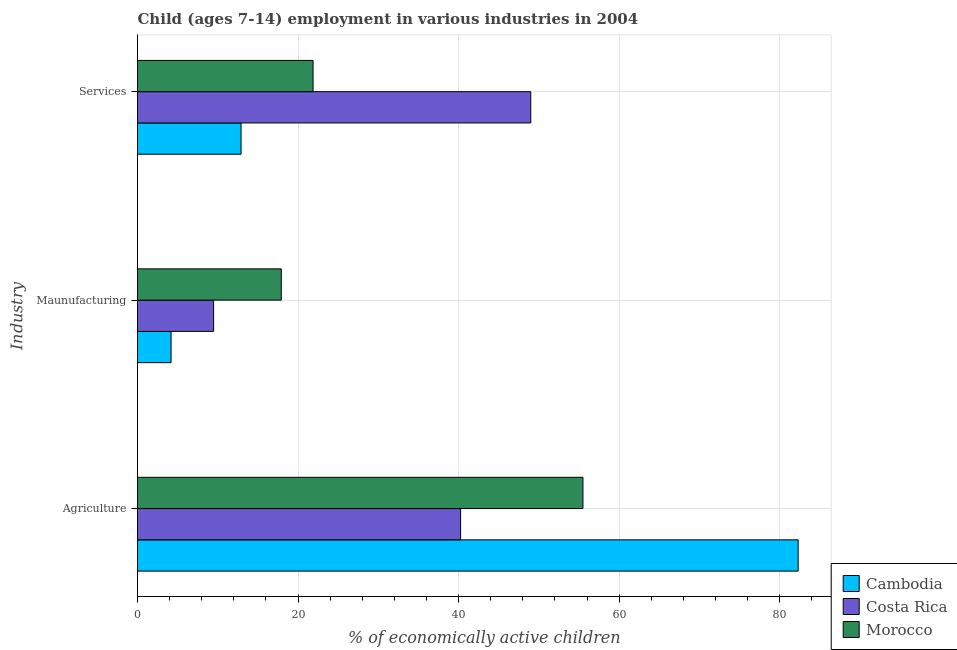Are the number of bars on each tick of the Y-axis equal?
Keep it short and to the point. Yes. How many bars are there on the 3rd tick from the top?
Provide a succinct answer. 3. How many bars are there on the 1st tick from the bottom?
Your response must be concise. 3. What is the label of the 3rd group of bars from the top?
Give a very brief answer. Agriculture. What is the percentage of economically active children in manufacturing in Morocco?
Provide a short and direct response. 17.91. Across all countries, what is the maximum percentage of economically active children in agriculture?
Make the answer very short. 82.3. Across all countries, what is the minimum percentage of economically active children in agriculture?
Ensure brevity in your answer.  40.25. In which country was the percentage of economically active children in agriculture maximum?
Offer a very short reply. Cambodia. What is the total percentage of economically active children in manufacturing in the graph?
Offer a very short reply. 31.57. What is the difference between the percentage of economically active children in manufacturing in Costa Rica and that in Morocco?
Offer a very short reply. -8.43. What is the difference between the percentage of economically active children in manufacturing in Morocco and the percentage of economically active children in services in Cambodia?
Ensure brevity in your answer.  5.01. What is the average percentage of economically active children in services per country?
Your answer should be very brief. 27.92. What is the difference between the percentage of economically active children in agriculture and percentage of economically active children in services in Morocco?
Provide a succinct answer. 33.62. In how many countries, is the percentage of economically active children in services greater than 60 %?
Ensure brevity in your answer.  0. What is the ratio of the percentage of economically active children in services in Cambodia to that in Costa Rica?
Make the answer very short. 0.26. Is the percentage of economically active children in agriculture in Morocco less than that in Costa Rica?
Offer a terse response. No. Is the difference between the percentage of economically active children in manufacturing in Cambodia and Costa Rica greater than the difference between the percentage of economically active children in services in Cambodia and Costa Rica?
Ensure brevity in your answer.  Yes. What is the difference between the highest and the second highest percentage of economically active children in manufacturing?
Provide a short and direct response. 8.43. What is the difference between the highest and the lowest percentage of economically active children in manufacturing?
Give a very brief answer. 13.73. In how many countries, is the percentage of economically active children in manufacturing greater than the average percentage of economically active children in manufacturing taken over all countries?
Your answer should be very brief. 1. What does the 2nd bar from the top in Agriculture represents?
Offer a terse response. Costa Rica. What does the 3rd bar from the bottom in Agriculture represents?
Offer a very short reply. Morocco. How many countries are there in the graph?
Offer a very short reply. 3. Are the values on the major ticks of X-axis written in scientific E-notation?
Your answer should be very brief. No. How many legend labels are there?
Provide a short and direct response. 3. What is the title of the graph?
Your answer should be compact. Child (ages 7-14) employment in various industries in 2004. What is the label or title of the X-axis?
Make the answer very short. % of economically active children. What is the label or title of the Y-axis?
Give a very brief answer. Industry. What is the % of economically active children in Cambodia in Agriculture?
Give a very brief answer. 82.3. What is the % of economically active children of Costa Rica in Agriculture?
Your response must be concise. 40.25. What is the % of economically active children of Morocco in Agriculture?
Your answer should be compact. 55.49. What is the % of economically active children of Cambodia in Maunufacturing?
Provide a short and direct response. 4.18. What is the % of economically active children in Costa Rica in Maunufacturing?
Keep it short and to the point. 9.48. What is the % of economically active children in Morocco in Maunufacturing?
Make the answer very short. 17.91. What is the % of economically active children of Costa Rica in Services?
Make the answer very short. 48.99. What is the % of economically active children of Morocco in Services?
Provide a short and direct response. 21.87. Across all Industry, what is the maximum % of economically active children in Cambodia?
Your response must be concise. 82.3. Across all Industry, what is the maximum % of economically active children in Costa Rica?
Make the answer very short. 48.99. Across all Industry, what is the maximum % of economically active children in Morocco?
Your answer should be very brief. 55.49. Across all Industry, what is the minimum % of economically active children in Cambodia?
Provide a short and direct response. 4.18. Across all Industry, what is the minimum % of economically active children in Costa Rica?
Provide a short and direct response. 9.48. Across all Industry, what is the minimum % of economically active children in Morocco?
Your answer should be very brief. 17.91. What is the total % of economically active children in Cambodia in the graph?
Keep it short and to the point. 99.38. What is the total % of economically active children of Costa Rica in the graph?
Provide a short and direct response. 98.72. What is the total % of economically active children in Morocco in the graph?
Your answer should be compact. 95.27. What is the difference between the % of economically active children in Cambodia in Agriculture and that in Maunufacturing?
Give a very brief answer. 78.12. What is the difference between the % of economically active children of Costa Rica in Agriculture and that in Maunufacturing?
Give a very brief answer. 30.77. What is the difference between the % of economically active children in Morocco in Agriculture and that in Maunufacturing?
Make the answer very short. 37.58. What is the difference between the % of economically active children of Cambodia in Agriculture and that in Services?
Offer a terse response. 69.4. What is the difference between the % of economically active children in Costa Rica in Agriculture and that in Services?
Your answer should be compact. -8.74. What is the difference between the % of economically active children of Morocco in Agriculture and that in Services?
Your response must be concise. 33.62. What is the difference between the % of economically active children of Cambodia in Maunufacturing and that in Services?
Offer a very short reply. -8.72. What is the difference between the % of economically active children of Costa Rica in Maunufacturing and that in Services?
Ensure brevity in your answer.  -39.51. What is the difference between the % of economically active children of Morocco in Maunufacturing and that in Services?
Make the answer very short. -3.96. What is the difference between the % of economically active children of Cambodia in Agriculture and the % of economically active children of Costa Rica in Maunufacturing?
Provide a succinct answer. 72.82. What is the difference between the % of economically active children in Cambodia in Agriculture and the % of economically active children in Morocco in Maunufacturing?
Keep it short and to the point. 64.39. What is the difference between the % of economically active children in Costa Rica in Agriculture and the % of economically active children in Morocco in Maunufacturing?
Your response must be concise. 22.34. What is the difference between the % of economically active children in Cambodia in Agriculture and the % of economically active children in Costa Rica in Services?
Offer a very short reply. 33.31. What is the difference between the % of economically active children of Cambodia in Agriculture and the % of economically active children of Morocco in Services?
Make the answer very short. 60.43. What is the difference between the % of economically active children in Costa Rica in Agriculture and the % of economically active children in Morocco in Services?
Your answer should be compact. 18.38. What is the difference between the % of economically active children of Cambodia in Maunufacturing and the % of economically active children of Costa Rica in Services?
Your answer should be very brief. -44.81. What is the difference between the % of economically active children of Cambodia in Maunufacturing and the % of economically active children of Morocco in Services?
Offer a terse response. -17.69. What is the difference between the % of economically active children in Costa Rica in Maunufacturing and the % of economically active children in Morocco in Services?
Keep it short and to the point. -12.39. What is the average % of economically active children of Cambodia per Industry?
Ensure brevity in your answer.  33.13. What is the average % of economically active children of Costa Rica per Industry?
Offer a very short reply. 32.91. What is the average % of economically active children in Morocco per Industry?
Offer a very short reply. 31.76. What is the difference between the % of economically active children of Cambodia and % of economically active children of Costa Rica in Agriculture?
Give a very brief answer. 42.05. What is the difference between the % of economically active children in Cambodia and % of economically active children in Morocco in Agriculture?
Your response must be concise. 26.81. What is the difference between the % of economically active children of Costa Rica and % of economically active children of Morocco in Agriculture?
Give a very brief answer. -15.24. What is the difference between the % of economically active children of Cambodia and % of economically active children of Morocco in Maunufacturing?
Keep it short and to the point. -13.73. What is the difference between the % of economically active children of Costa Rica and % of economically active children of Morocco in Maunufacturing?
Your answer should be compact. -8.43. What is the difference between the % of economically active children of Cambodia and % of economically active children of Costa Rica in Services?
Make the answer very short. -36.09. What is the difference between the % of economically active children of Cambodia and % of economically active children of Morocco in Services?
Your answer should be compact. -8.97. What is the difference between the % of economically active children in Costa Rica and % of economically active children in Morocco in Services?
Your response must be concise. 27.12. What is the ratio of the % of economically active children of Cambodia in Agriculture to that in Maunufacturing?
Provide a succinct answer. 19.69. What is the ratio of the % of economically active children of Costa Rica in Agriculture to that in Maunufacturing?
Ensure brevity in your answer.  4.25. What is the ratio of the % of economically active children of Morocco in Agriculture to that in Maunufacturing?
Your answer should be very brief. 3.1. What is the ratio of the % of economically active children in Cambodia in Agriculture to that in Services?
Offer a terse response. 6.38. What is the ratio of the % of economically active children in Costa Rica in Agriculture to that in Services?
Provide a short and direct response. 0.82. What is the ratio of the % of economically active children of Morocco in Agriculture to that in Services?
Provide a succinct answer. 2.54. What is the ratio of the % of economically active children in Cambodia in Maunufacturing to that in Services?
Your answer should be compact. 0.32. What is the ratio of the % of economically active children in Costa Rica in Maunufacturing to that in Services?
Your answer should be very brief. 0.19. What is the ratio of the % of economically active children of Morocco in Maunufacturing to that in Services?
Keep it short and to the point. 0.82. What is the difference between the highest and the second highest % of economically active children of Cambodia?
Keep it short and to the point. 69.4. What is the difference between the highest and the second highest % of economically active children in Costa Rica?
Provide a short and direct response. 8.74. What is the difference between the highest and the second highest % of economically active children in Morocco?
Ensure brevity in your answer.  33.62. What is the difference between the highest and the lowest % of economically active children of Cambodia?
Your response must be concise. 78.12. What is the difference between the highest and the lowest % of economically active children of Costa Rica?
Offer a terse response. 39.51. What is the difference between the highest and the lowest % of economically active children in Morocco?
Provide a short and direct response. 37.58. 